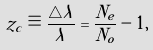<formula> <loc_0><loc_0><loc_500><loc_500>z _ { c } \equiv \frac { \triangle \lambda } { \lambda } = \frac { N _ { e } } { N _ { o } } - 1 ,</formula> 